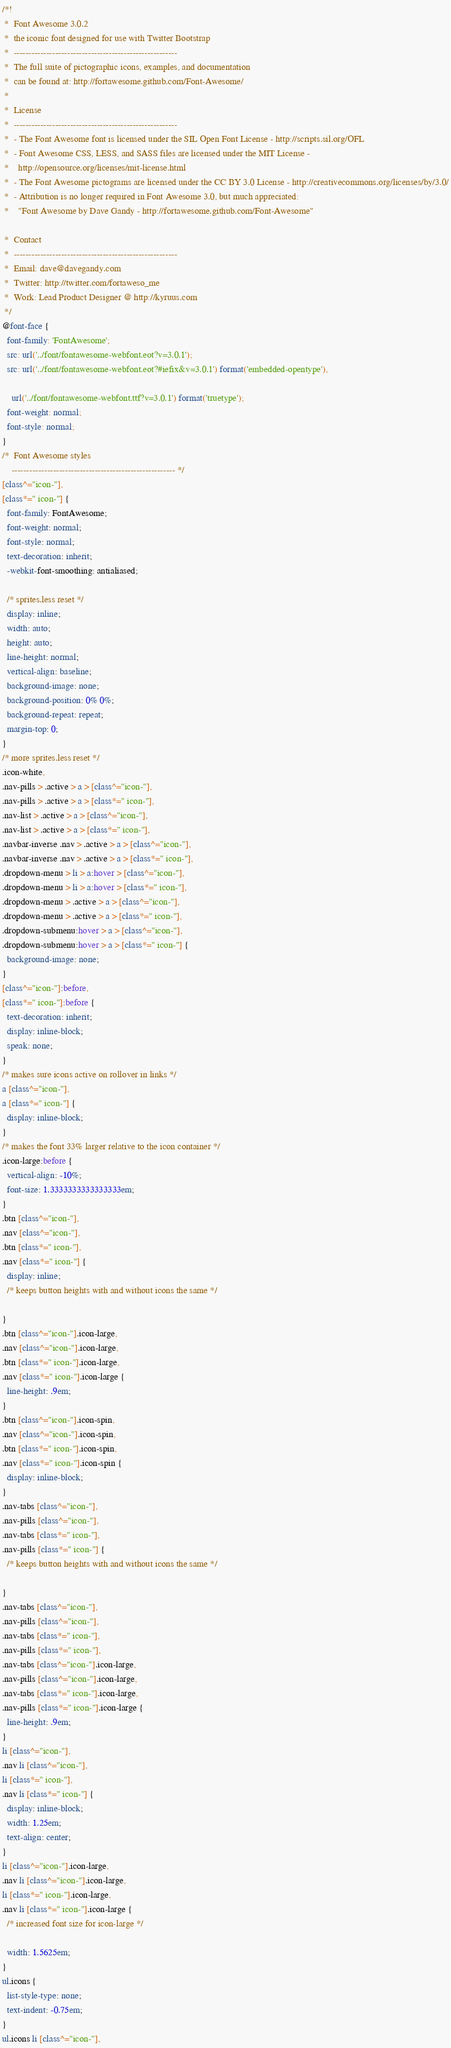Convert code to text. <code><loc_0><loc_0><loc_500><loc_500><_CSS_>/*!
 *  Font Awesome 3.0.2
 *  the iconic font designed for use with Twitter Bootstrap
 *  -------------------------------------------------------
 *  The full suite of pictographic icons, examples, and documentation
 *  can be found at: http://fortawesome.github.com/Font-Awesome/
 *
 *  License
 *  -------------------------------------------------------
 *  - The Font Awesome font is licensed under the SIL Open Font License - http://scripts.sil.org/OFL
 *  - Font Awesome CSS, LESS, and SASS files are licensed under the MIT License -
 *    http://opensource.org/licenses/mit-license.html
 *  - The Font Awesome pictograms are licensed under the CC BY 3.0 License - http://creativecommons.org/licenses/by/3.0/
 *  - Attribution is no longer required in Font Awesome 3.0, but much appreciated:
 *    "Font Awesome by Dave Gandy - http://fortawesome.github.com/Font-Awesome"

 *  Contact
 *  -------------------------------------------------------
 *  Email: dave@davegandy.com
 *  Twitter: http://twitter.com/fortaweso_me
 *  Work: Lead Product Designer @ http://kyruus.com
 */
@font-face {
  font-family: 'FontAwesome';
  src: url('../font/fontawesome-webfont.eot?v=3.0.1');
  src: url('../font/fontawesome-webfont.eot?#iefix&v=3.0.1') format('embedded-opentype'),
    
    url('../font/fontawesome-webfont.ttf?v=3.0.1') format('truetype');
  font-weight: normal;
  font-style: normal;
}
/*  Font Awesome styles
    ------------------------------------------------------- */
[class^="icon-"],
[class*=" icon-"] {
  font-family: FontAwesome;
  font-weight: normal;
  font-style: normal;
  text-decoration: inherit;
  -webkit-font-smoothing: antialiased;

  /* sprites.less reset */
  display: inline;
  width: auto;
  height: auto;
  line-height: normal;
  vertical-align: baseline;
  background-image: none;
  background-position: 0% 0%;
  background-repeat: repeat;
  margin-top: 0;
}
/* more sprites.less reset */
.icon-white,
.nav-pills > .active > a > [class^="icon-"],
.nav-pills > .active > a > [class*=" icon-"],
.nav-list > .active > a > [class^="icon-"],
.nav-list > .active > a > [class*=" icon-"],
.navbar-inverse .nav > .active > a > [class^="icon-"],
.navbar-inverse .nav > .active > a > [class*=" icon-"],
.dropdown-menu > li > a:hover > [class^="icon-"],
.dropdown-menu > li > a:hover > [class*=" icon-"],
.dropdown-menu > .active > a > [class^="icon-"],
.dropdown-menu > .active > a > [class*=" icon-"],
.dropdown-submenu:hover > a > [class^="icon-"],
.dropdown-submenu:hover > a > [class*=" icon-"] {
  background-image: none;
}
[class^="icon-"]:before,
[class*=" icon-"]:before {
  text-decoration: inherit;
  display: inline-block;
  speak: none;
}
/* makes sure icons active on rollover in links */
a [class^="icon-"],
a [class*=" icon-"] {
  display: inline-block;
}
/* makes the font 33% larger relative to the icon container */
.icon-large:before {
  vertical-align: -10%;
  font-size: 1.3333333333333333em;
}
.btn [class^="icon-"],
.nav [class^="icon-"],
.btn [class*=" icon-"],
.nav [class*=" icon-"] {
  display: inline;
  /* keeps button heights with and without icons the same */

}
.btn [class^="icon-"].icon-large,
.nav [class^="icon-"].icon-large,
.btn [class*=" icon-"].icon-large,
.nav [class*=" icon-"].icon-large {
  line-height: .9em;
}
.btn [class^="icon-"].icon-spin,
.nav [class^="icon-"].icon-spin,
.btn [class*=" icon-"].icon-spin,
.nav [class*=" icon-"].icon-spin {
  display: inline-block;
}
.nav-tabs [class^="icon-"],
.nav-pills [class^="icon-"],
.nav-tabs [class*=" icon-"],
.nav-pills [class*=" icon-"] {
  /* keeps button heights with and without icons the same */

}
.nav-tabs [class^="icon-"],
.nav-pills [class^="icon-"],
.nav-tabs [class*=" icon-"],
.nav-pills [class*=" icon-"],
.nav-tabs [class^="icon-"].icon-large,
.nav-pills [class^="icon-"].icon-large,
.nav-tabs [class*=" icon-"].icon-large,
.nav-pills [class*=" icon-"].icon-large {
  line-height: .9em;
}
li [class^="icon-"],
.nav li [class^="icon-"],
li [class*=" icon-"],
.nav li [class*=" icon-"] {
  display: inline-block;
  width: 1.25em;
  text-align: center;
}
li [class^="icon-"].icon-large,
.nav li [class^="icon-"].icon-large,
li [class*=" icon-"].icon-large,
.nav li [class*=" icon-"].icon-large {
  /* increased font size for icon-large */

  width: 1.5625em;
}
ul.icons {
  list-style-type: none;
  text-indent: -0.75em;
}
ul.icons li [class^="icon-"],</code> 